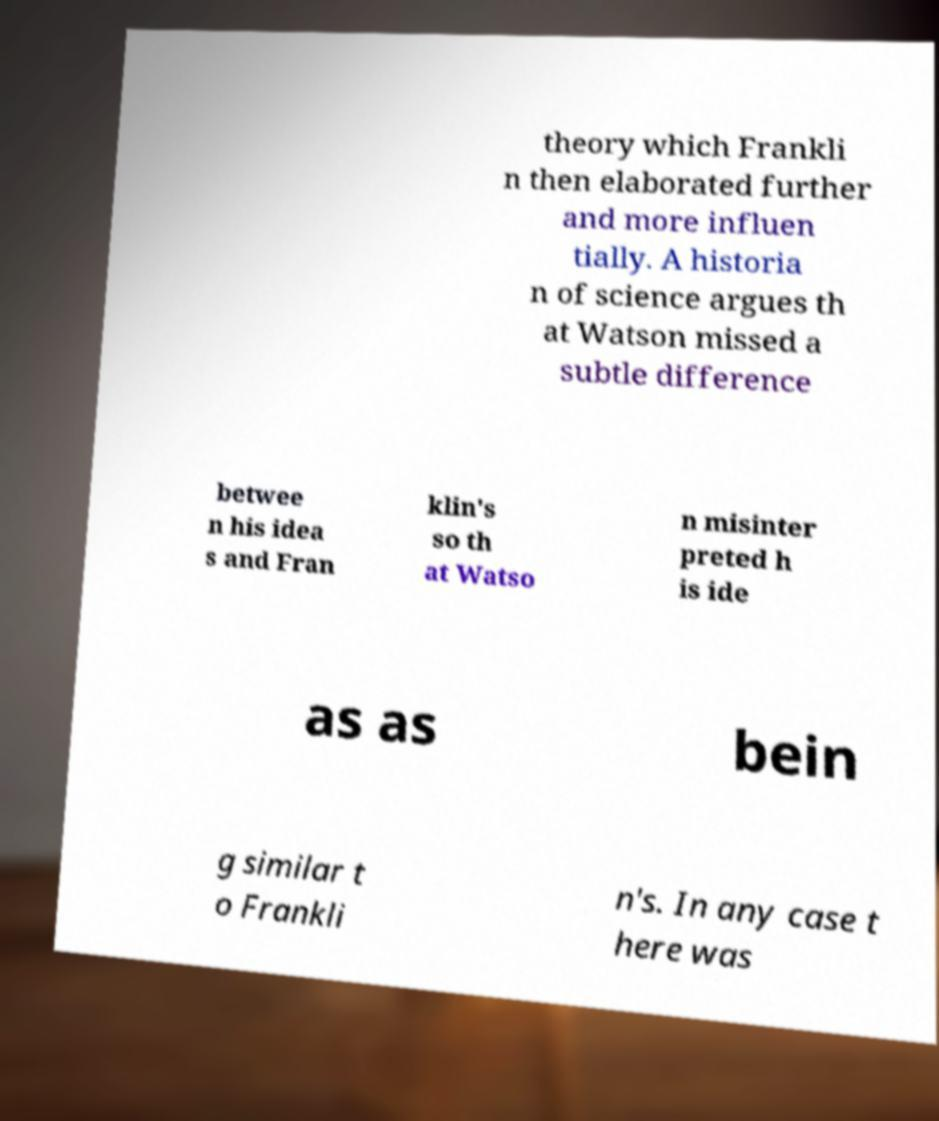Can you read and provide the text displayed in the image?This photo seems to have some interesting text. Can you extract and type it out for me? theory which Frankli n then elaborated further and more influen tially. A historia n of science argues th at Watson missed a subtle difference betwee n his idea s and Fran klin's so th at Watso n misinter preted h is ide as as bein g similar t o Frankli n's. In any case t here was 